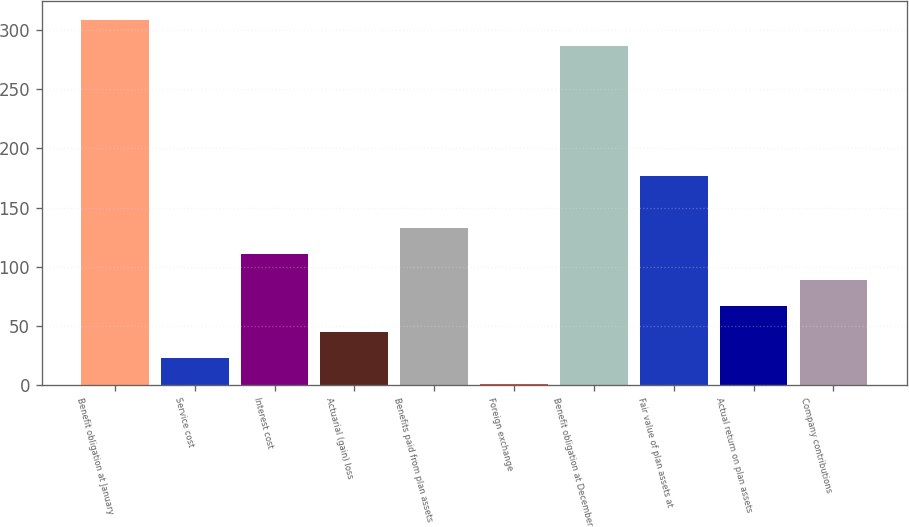<chart> <loc_0><loc_0><loc_500><loc_500><bar_chart><fcel>Benefit obligation at January<fcel>Service cost<fcel>Interest cost<fcel>Actuarial (gain) loss<fcel>Benefits paid from plan assets<fcel>Foreign exchange<fcel>Benefit obligation at December<fcel>Fair value of plan assets at<fcel>Actual return on plan assets<fcel>Company contributions<nl><fcel>309<fcel>23<fcel>111<fcel>45<fcel>133<fcel>1<fcel>287<fcel>177<fcel>67<fcel>89<nl></chart> 